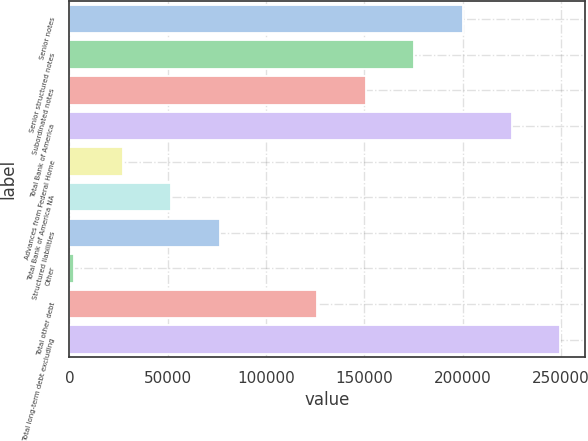<chart> <loc_0><loc_0><loc_500><loc_500><bar_chart><fcel>Senior notes<fcel>Senior structured notes<fcel>Subordinated notes<fcel>Total Bank of America<fcel>Advances from Federal Home<fcel>Total Bank of America NA<fcel>Structured liabilities<fcel>Other<fcel>Total other debt<fcel>Total long-term debt excluding<nl><fcel>200224<fcel>175498<fcel>150773<fcel>224949<fcel>27147.2<fcel>51872.4<fcel>76597.6<fcel>2422<fcel>126048<fcel>249674<nl></chart> 